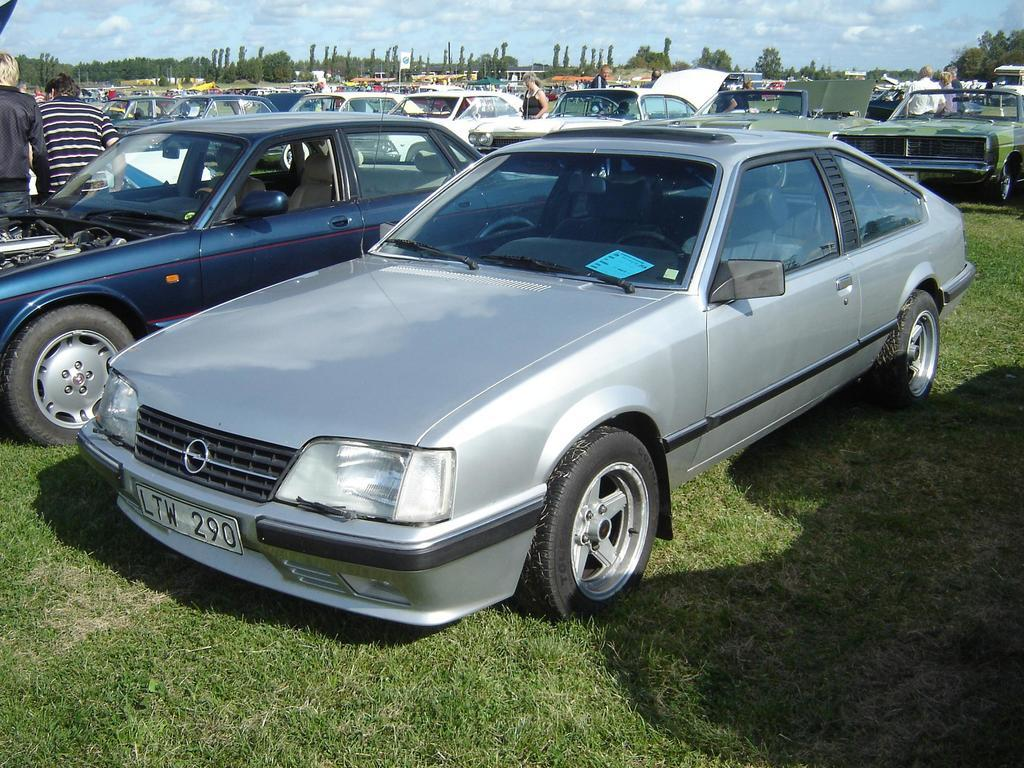What types of objects are present in the image? There are vehicles and people in the image. What can be seen at the bottom of the image? There is grass at the bottom of the image. What is visible in the background of the image? There are trees, a pole, and a board in the background of the image. What is visible at the top of the image? The sky is visible at the top of the image. Can you see a pig using a toothbrush in the image? No, there is no pig or toothbrush present in the image. 